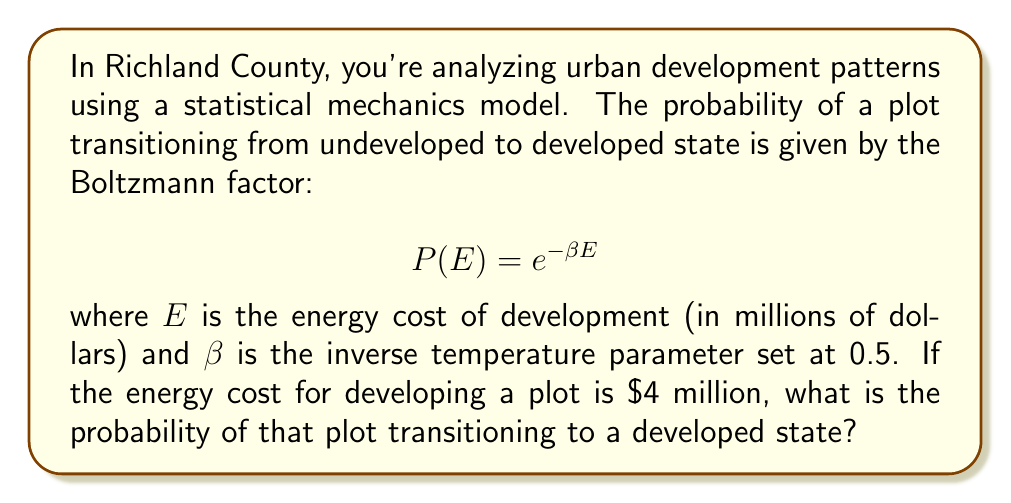Can you answer this question? To solve this problem, we'll follow these steps:

1. Identify the given information:
   - The probability is given by the Boltzmann factor: $P(E) = e^{-\beta E}$
   - $\beta = 0.5$
   - $E = 4$ million dollars

2. Substitute the values into the Boltzmann factor equation:
   $P(E) = e^{-0.5 \cdot 4}$

3. Simplify the exponent:
   $P(E) = e^{-2}$

4. Calculate the value of $e^{-2}$:
   $P(E) \approx 0.1353$

5. Convert to a percentage:
   $P(E) \approx 13.53\%$

This result indicates that there is approximately a 13.53% chance of the plot transitioning from an undeveloped to a developed state given the specified energy cost and inverse temperature parameter.
Answer: 13.53% 